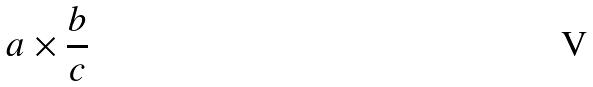<formula> <loc_0><loc_0><loc_500><loc_500>a \times \frac { b } { c }</formula> 